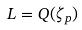Convert formula to latex. <formula><loc_0><loc_0><loc_500><loc_500>L = Q ( \zeta _ { p } )</formula> 